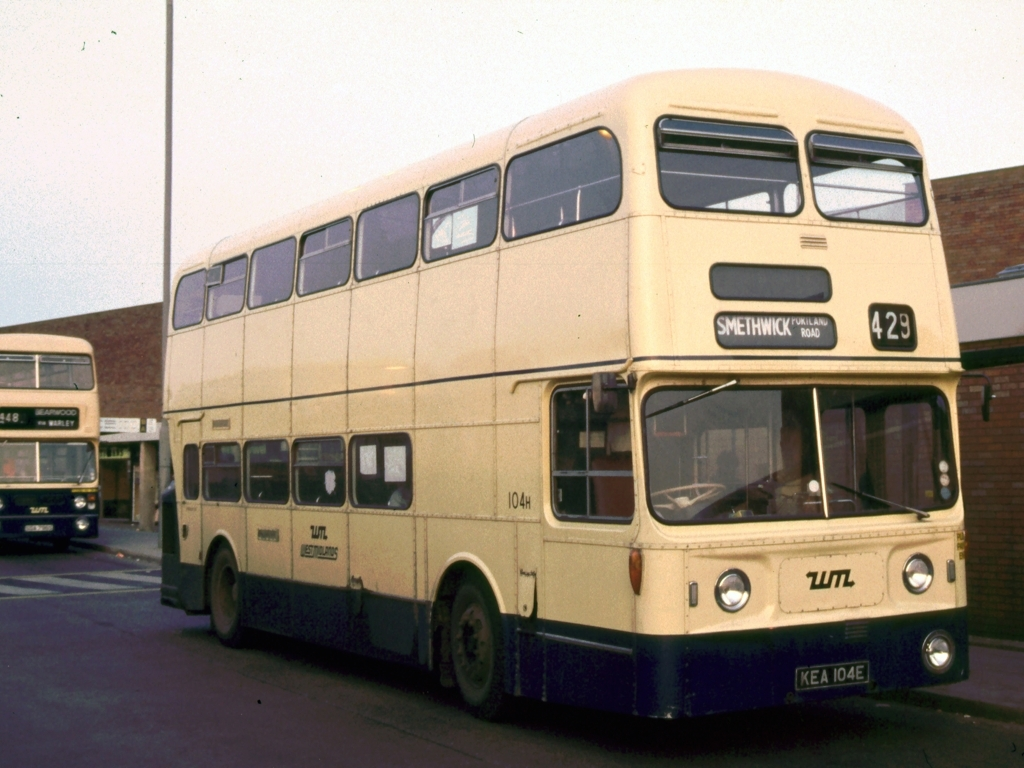What kind of engine might this bus have? Buses of this era typically were equipped with diesel engines. Given its size and the period it's from, it's likely to have a large displacement inline or V-type diesel engine designed for the torque necessary to move a double-decker bus efficiently. 